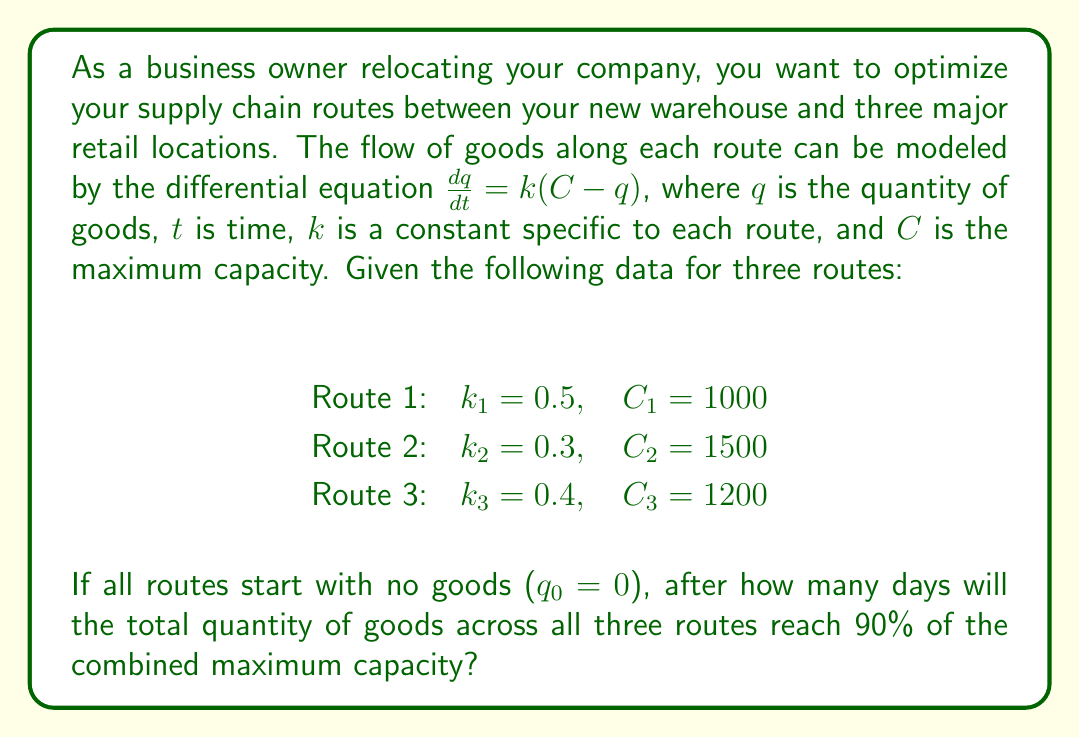What is the answer to this math problem? To solve this problem, we need to follow these steps:

1) First, let's recall the solution to the differential equation $\frac{dq}{dt} = k(C - q)$:
   
   $q(t) = C(1 - e^{-kt})$

2) We need to find the time $t$ when the sum of all three routes reaches 90% of the total capacity. Let's set up the equation:

   $q_1(t) + q_2(t) + q_3(t) = 0.9(C_1 + C_2 + C_3)$

3) Substituting the solution for each route:

   $C_1(1 - e^{-k_1t}) + C_2(1 - e^{-k_2t}) + C_3(1 - e^{-k_3t}) = 0.9(C_1 + C_2 + C_3)$

4) Plugging in the values:

   $1000(1 - e^{-0.5t}) + 1500(1 - e^{-0.3t}) + 1200(1 - e^{-0.4t}) = 0.9(1000 + 1500 + 1200)$

5) Simplifying the right side:

   $1000(1 - e^{-0.5t}) + 1500(1 - e^{-0.3t}) + 1200(1 - e^{-0.4t}) = 3330$

6) Expanding the left side:

   $1000 + 1500 + 1200 - 1000e^{-0.5t} - 1500e^{-0.3t} - 1200e^{-0.4t} = 3330$

7) Simplifying:

   $3700 - 1000e^{-0.5t} - 1500e^{-0.3t} - 1200e^{-0.4t} = 3330$

8) Subtracting 3330 from both sides:

   $370 = 1000e^{-0.5t} + 1500e^{-0.3t} + 1200e^{-0.4t}$

9) This equation cannot be solved algebraically. We need to use numerical methods or graphing to find $t$. Using a numerical solver, we find that $t \approx 4.6$ days.

10) Rounding up to the nearest whole day, we get 5 days.
Answer: 5 days 